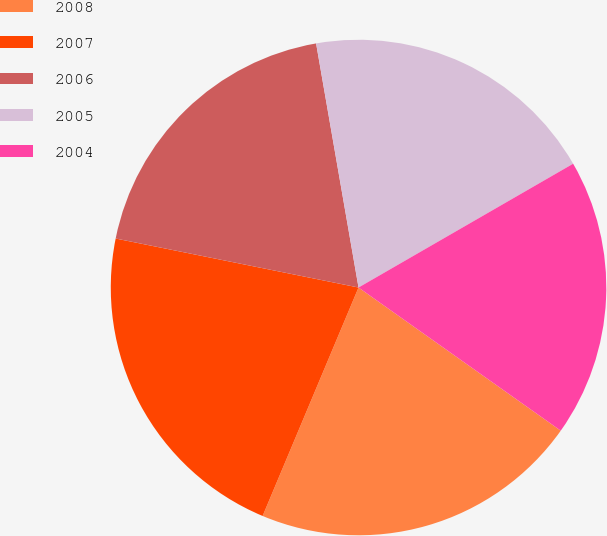<chart> <loc_0><loc_0><loc_500><loc_500><pie_chart><fcel>2008<fcel>2007<fcel>2006<fcel>2005<fcel>2004<nl><fcel>21.52%<fcel>21.84%<fcel>19.09%<fcel>19.41%<fcel>18.13%<nl></chart> 